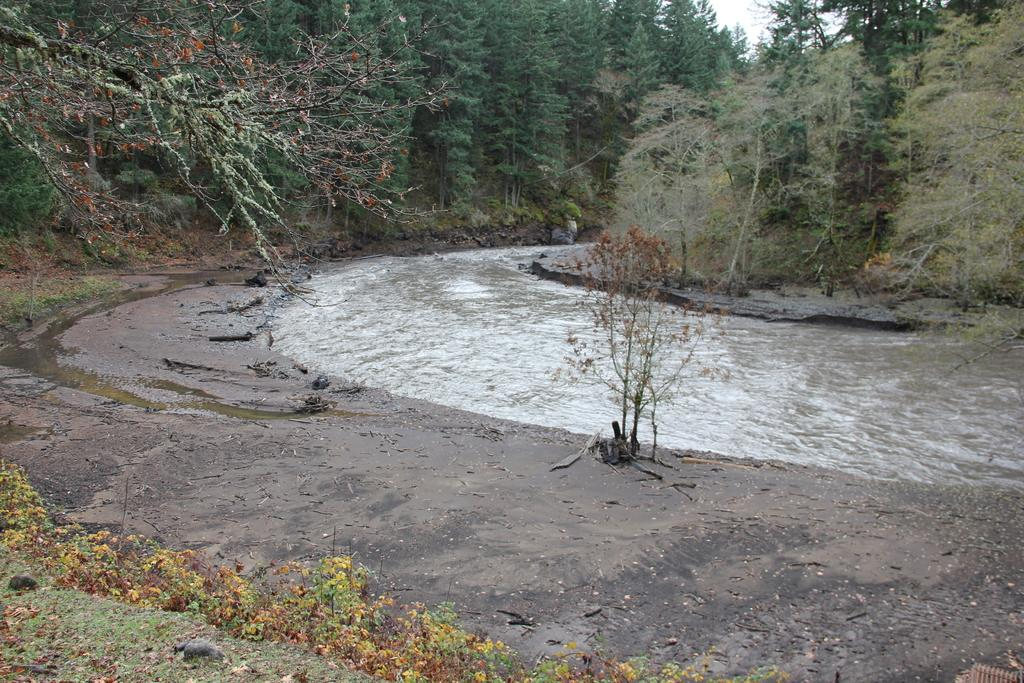What type of vegetation can be seen in the image? There are trees, bushes, plants, and grass in the image. What natural feature is present in the image? There is a river in the image. What type of ground cover is visible in the image? There are stones in the image. What is located on the surface in the image? There is an object on the surface. What is visible at the top of the image? The sky is visible at the top of the image. What type of salt can be seen on the plate in the image? There is no plate or salt present in the image. What kind of pets are visible in the image? There are no pets visible in the image. 